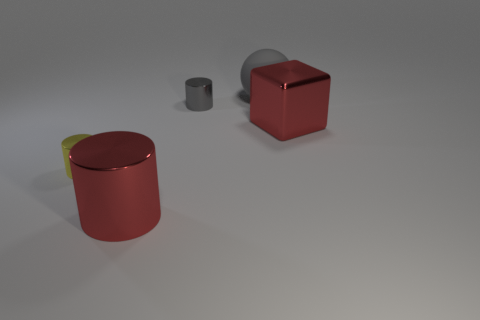Add 2 large cyan metal things. How many objects exist? 7 Subtract all cylinders. How many objects are left? 2 Subtract 0 cyan balls. How many objects are left? 5 Subtract all large gray objects. Subtract all big cylinders. How many objects are left? 3 Add 1 gray rubber balls. How many gray rubber balls are left? 2 Add 3 red cubes. How many red cubes exist? 4 